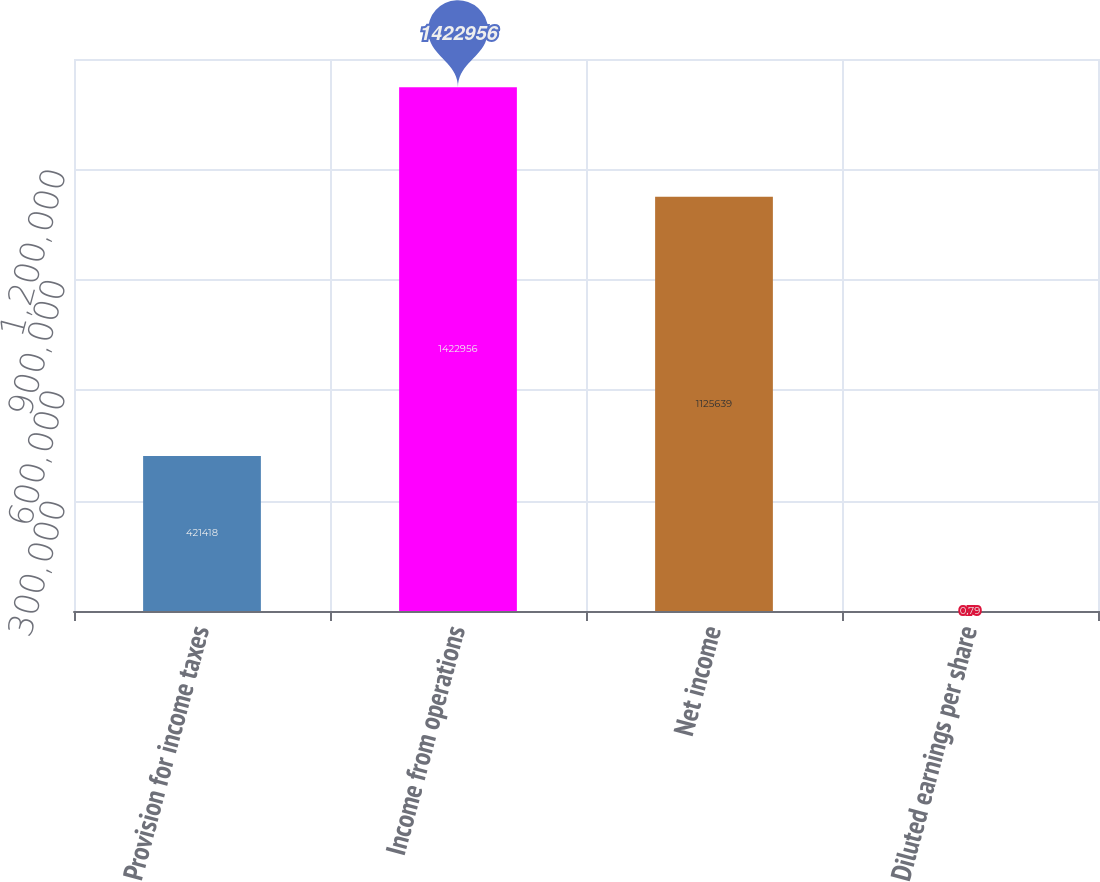Convert chart. <chart><loc_0><loc_0><loc_500><loc_500><bar_chart><fcel>Provision for income taxes<fcel>Income from operations<fcel>Net income<fcel>Diluted earnings per share<nl><fcel>421418<fcel>1.42296e+06<fcel>1.12564e+06<fcel>0.79<nl></chart> 